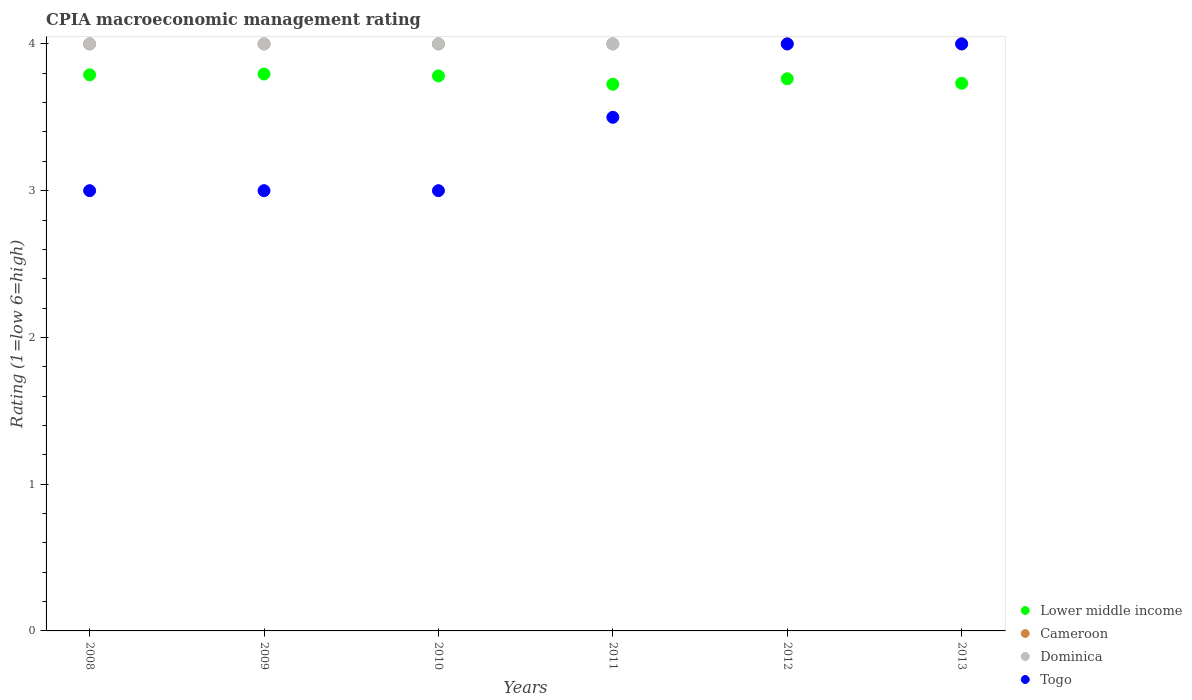Is the number of dotlines equal to the number of legend labels?
Offer a very short reply. Yes. What is the CPIA rating in Togo in 2013?
Provide a short and direct response. 4. Across all years, what is the maximum CPIA rating in Cameroon?
Ensure brevity in your answer.  4. In which year was the CPIA rating in Cameroon maximum?
Provide a short and direct response. 2008. What is the total CPIA rating in Cameroon in the graph?
Ensure brevity in your answer.  24. What is the difference between the CPIA rating in Dominica in 2008 and that in 2009?
Your answer should be very brief. 0. What is the difference between the CPIA rating in Lower middle income in 2010 and the CPIA rating in Dominica in 2009?
Keep it short and to the point. -0.22. In the year 2013, what is the difference between the CPIA rating in Dominica and CPIA rating in Lower middle income?
Offer a terse response. 0.27. What is the ratio of the CPIA rating in Lower middle income in 2010 to that in 2011?
Offer a terse response. 1.02. Is the difference between the CPIA rating in Dominica in 2009 and 2012 greater than the difference between the CPIA rating in Lower middle income in 2009 and 2012?
Give a very brief answer. No. What is the difference between the highest and the second highest CPIA rating in Togo?
Your answer should be compact. 0. Is the sum of the CPIA rating in Dominica in 2012 and 2013 greater than the maximum CPIA rating in Togo across all years?
Provide a succinct answer. Yes. Does the CPIA rating in Togo monotonically increase over the years?
Offer a very short reply. No. Is the CPIA rating in Cameroon strictly greater than the CPIA rating in Togo over the years?
Make the answer very short. No. Is the CPIA rating in Cameroon strictly less than the CPIA rating in Dominica over the years?
Give a very brief answer. No. How many years are there in the graph?
Offer a very short reply. 6. What is the difference between two consecutive major ticks on the Y-axis?
Provide a short and direct response. 1. Are the values on the major ticks of Y-axis written in scientific E-notation?
Your answer should be very brief. No. Does the graph contain grids?
Give a very brief answer. No. Where does the legend appear in the graph?
Your answer should be compact. Bottom right. What is the title of the graph?
Provide a short and direct response. CPIA macroeconomic management rating. Does "United States" appear as one of the legend labels in the graph?
Ensure brevity in your answer.  No. What is the label or title of the X-axis?
Keep it short and to the point. Years. What is the Rating (1=low 6=high) of Lower middle income in 2008?
Provide a succinct answer. 3.79. What is the Rating (1=low 6=high) of Cameroon in 2008?
Your answer should be compact. 4. What is the Rating (1=low 6=high) of Togo in 2008?
Provide a short and direct response. 3. What is the Rating (1=low 6=high) of Lower middle income in 2009?
Keep it short and to the point. 3.79. What is the Rating (1=low 6=high) of Lower middle income in 2010?
Offer a very short reply. 3.78. What is the Rating (1=low 6=high) of Cameroon in 2010?
Make the answer very short. 4. What is the Rating (1=low 6=high) in Togo in 2010?
Your answer should be compact. 3. What is the Rating (1=low 6=high) in Lower middle income in 2011?
Offer a very short reply. 3.73. What is the Rating (1=low 6=high) in Cameroon in 2011?
Offer a very short reply. 4. What is the Rating (1=low 6=high) of Dominica in 2011?
Offer a very short reply. 4. What is the Rating (1=low 6=high) of Lower middle income in 2012?
Your answer should be very brief. 3.76. What is the Rating (1=low 6=high) of Cameroon in 2012?
Ensure brevity in your answer.  4. What is the Rating (1=low 6=high) of Togo in 2012?
Offer a terse response. 4. What is the Rating (1=low 6=high) in Lower middle income in 2013?
Give a very brief answer. 3.73. What is the Rating (1=low 6=high) in Cameroon in 2013?
Keep it short and to the point. 4. What is the Rating (1=low 6=high) of Dominica in 2013?
Provide a short and direct response. 4. Across all years, what is the maximum Rating (1=low 6=high) of Lower middle income?
Provide a succinct answer. 3.79. Across all years, what is the maximum Rating (1=low 6=high) of Dominica?
Offer a terse response. 4. Across all years, what is the maximum Rating (1=low 6=high) of Togo?
Your answer should be very brief. 4. Across all years, what is the minimum Rating (1=low 6=high) in Lower middle income?
Offer a very short reply. 3.73. What is the total Rating (1=low 6=high) in Lower middle income in the graph?
Provide a short and direct response. 22.59. What is the total Rating (1=low 6=high) of Cameroon in the graph?
Your answer should be compact. 24. What is the difference between the Rating (1=low 6=high) in Lower middle income in 2008 and that in 2009?
Your answer should be very brief. -0.01. What is the difference between the Rating (1=low 6=high) in Cameroon in 2008 and that in 2009?
Make the answer very short. 0. What is the difference between the Rating (1=low 6=high) in Lower middle income in 2008 and that in 2010?
Offer a very short reply. 0.01. What is the difference between the Rating (1=low 6=high) in Cameroon in 2008 and that in 2010?
Provide a succinct answer. 0. What is the difference between the Rating (1=low 6=high) in Togo in 2008 and that in 2010?
Ensure brevity in your answer.  0. What is the difference between the Rating (1=low 6=high) in Lower middle income in 2008 and that in 2011?
Your answer should be compact. 0.06. What is the difference between the Rating (1=low 6=high) of Dominica in 2008 and that in 2011?
Provide a short and direct response. 0. What is the difference between the Rating (1=low 6=high) in Lower middle income in 2008 and that in 2012?
Make the answer very short. 0.03. What is the difference between the Rating (1=low 6=high) of Cameroon in 2008 and that in 2012?
Make the answer very short. 0. What is the difference between the Rating (1=low 6=high) in Dominica in 2008 and that in 2012?
Your answer should be very brief. 0. What is the difference between the Rating (1=low 6=high) of Lower middle income in 2008 and that in 2013?
Your answer should be very brief. 0.06. What is the difference between the Rating (1=low 6=high) of Cameroon in 2008 and that in 2013?
Keep it short and to the point. 0. What is the difference between the Rating (1=low 6=high) in Dominica in 2008 and that in 2013?
Your response must be concise. 0. What is the difference between the Rating (1=low 6=high) in Togo in 2008 and that in 2013?
Offer a very short reply. -1. What is the difference between the Rating (1=low 6=high) of Lower middle income in 2009 and that in 2010?
Ensure brevity in your answer.  0.01. What is the difference between the Rating (1=low 6=high) of Cameroon in 2009 and that in 2010?
Your answer should be very brief. 0. What is the difference between the Rating (1=low 6=high) in Lower middle income in 2009 and that in 2011?
Ensure brevity in your answer.  0.07. What is the difference between the Rating (1=low 6=high) of Togo in 2009 and that in 2011?
Provide a succinct answer. -0.5. What is the difference between the Rating (1=low 6=high) in Lower middle income in 2009 and that in 2012?
Give a very brief answer. 0.03. What is the difference between the Rating (1=low 6=high) of Cameroon in 2009 and that in 2012?
Make the answer very short. 0. What is the difference between the Rating (1=low 6=high) of Dominica in 2009 and that in 2012?
Offer a terse response. 0. What is the difference between the Rating (1=low 6=high) of Lower middle income in 2009 and that in 2013?
Ensure brevity in your answer.  0.06. What is the difference between the Rating (1=low 6=high) of Cameroon in 2009 and that in 2013?
Ensure brevity in your answer.  0. What is the difference between the Rating (1=low 6=high) of Lower middle income in 2010 and that in 2011?
Give a very brief answer. 0.06. What is the difference between the Rating (1=low 6=high) of Togo in 2010 and that in 2011?
Your response must be concise. -0.5. What is the difference between the Rating (1=low 6=high) of Lower middle income in 2010 and that in 2012?
Make the answer very short. 0.02. What is the difference between the Rating (1=low 6=high) of Lower middle income in 2010 and that in 2013?
Make the answer very short. 0.05. What is the difference between the Rating (1=low 6=high) of Dominica in 2010 and that in 2013?
Make the answer very short. 0. What is the difference between the Rating (1=low 6=high) of Togo in 2010 and that in 2013?
Make the answer very short. -1. What is the difference between the Rating (1=low 6=high) in Lower middle income in 2011 and that in 2012?
Ensure brevity in your answer.  -0.04. What is the difference between the Rating (1=low 6=high) in Cameroon in 2011 and that in 2012?
Keep it short and to the point. 0. What is the difference between the Rating (1=low 6=high) of Lower middle income in 2011 and that in 2013?
Provide a short and direct response. -0.01. What is the difference between the Rating (1=low 6=high) of Dominica in 2011 and that in 2013?
Your answer should be very brief. 0. What is the difference between the Rating (1=low 6=high) of Togo in 2011 and that in 2013?
Offer a terse response. -0.5. What is the difference between the Rating (1=low 6=high) of Lower middle income in 2012 and that in 2013?
Provide a succinct answer. 0.03. What is the difference between the Rating (1=low 6=high) in Cameroon in 2012 and that in 2013?
Make the answer very short. 0. What is the difference between the Rating (1=low 6=high) of Dominica in 2012 and that in 2013?
Make the answer very short. 0. What is the difference between the Rating (1=low 6=high) of Lower middle income in 2008 and the Rating (1=low 6=high) of Cameroon in 2009?
Keep it short and to the point. -0.21. What is the difference between the Rating (1=low 6=high) in Lower middle income in 2008 and the Rating (1=low 6=high) in Dominica in 2009?
Keep it short and to the point. -0.21. What is the difference between the Rating (1=low 6=high) of Lower middle income in 2008 and the Rating (1=low 6=high) of Togo in 2009?
Ensure brevity in your answer.  0.79. What is the difference between the Rating (1=low 6=high) of Cameroon in 2008 and the Rating (1=low 6=high) of Togo in 2009?
Your answer should be compact. 1. What is the difference between the Rating (1=low 6=high) in Dominica in 2008 and the Rating (1=low 6=high) in Togo in 2009?
Keep it short and to the point. 1. What is the difference between the Rating (1=low 6=high) in Lower middle income in 2008 and the Rating (1=low 6=high) in Cameroon in 2010?
Give a very brief answer. -0.21. What is the difference between the Rating (1=low 6=high) in Lower middle income in 2008 and the Rating (1=low 6=high) in Dominica in 2010?
Make the answer very short. -0.21. What is the difference between the Rating (1=low 6=high) in Lower middle income in 2008 and the Rating (1=low 6=high) in Togo in 2010?
Provide a succinct answer. 0.79. What is the difference between the Rating (1=low 6=high) of Dominica in 2008 and the Rating (1=low 6=high) of Togo in 2010?
Make the answer very short. 1. What is the difference between the Rating (1=low 6=high) in Lower middle income in 2008 and the Rating (1=low 6=high) in Cameroon in 2011?
Provide a short and direct response. -0.21. What is the difference between the Rating (1=low 6=high) of Lower middle income in 2008 and the Rating (1=low 6=high) of Dominica in 2011?
Your answer should be compact. -0.21. What is the difference between the Rating (1=low 6=high) in Lower middle income in 2008 and the Rating (1=low 6=high) in Togo in 2011?
Give a very brief answer. 0.29. What is the difference between the Rating (1=low 6=high) of Cameroon in 2008 and the Rating (1=low 6=high) of Dominica in 2011?
Your response must be concise. 0. What is the difference between the Rating (1=low 6=high) of Lower middle income in 2008 and the Rating (1=low 6=high) of Cameroon in 2012?
Provide a succinct answer. -0.21. What is the difference between the Rating (1=low 6=high) of Lower middle income in 2008 and the Rating (1=low 6=high) of Dominica in 2012?
Provide a short and direct response. -0.21. What is the difference between the Rating (1=low 6=high) of Lower middle income in 2008 and the Rating (1=low 6=high) of Togo in 2012?
Offer a terse response. -0.21. What is the difference between the Rating (1=low 6=high) in Cameroon in 2008 and the Rating (1=low 6=high) in Togo in 2012?
Give a very brief answer. 0. What is the difference between the Rating (1=low 6=high) of Dominica in 2008 and the Rating (1=low 6=high) of Togo in 2012?
Make the answer very short. 0. What is the difference between the Rating (1=low 6=high) of Lower middle income in 2008 and the Rating (1=low 6=high) of Cameroon in 2013?
Provide a short and direct response. -0.21. What is the difference between the Rating (1=low 6=high) in Lower middle income in 2008 and the Rating (1=low 6=high) in Dominica in 2013?
Offer a very short reply. -0.21. What is the difference between the Rating (1=low 6=high) of Lower middle income in 2008 and the Rating (1=low 6=high) of Togo in 2013?
Provide a succinct answer. -0.21. What is the difference between the Rating (1=low 6=high) in Cameroon in 2008 and the Rating (1=low 6=high) in Togo in 2013?
Offer a terse response. 0. What is the difference between the Rating (1=low 6=high) in Dominica in 2008 and the Rating (1=low 6=high) in Togo in 2013?
Offer a very short reply. 0. What is the difference between the Rating (1=low 6=high) of Lower middle income in 2009 and the Rating (1=low 6=high) of Cameroon in 2010?
Your answer should be compact. -0.21. What is the difference between the Rating (1=low 6=high) of Lower middle income in 2009 and the Rating (1=low 6=high) of Dominica in 2010?
Give a very brief answer. -0.21. What is the difference between the Rating (1=low 6=high) of Lower middle income in 2009 and the Rating (1=low 6=high) of Togo in 2010?
Make the answer very short. 0.79. What is the difference between the Rating (1=low 6=high) in Cameroon in 2009 and the Rating (1=low 6=high) in Dominica in 2010?
Make the answer very short. 0. What is the difference between the Rating (1=low 6=high) in Cameroon in 2009 and the Rating (1=low 6=high) in Togo in 2010?
Offer a terse response. 1. What is the difference between the Rating (1=low 6=high) of Lower middle income in 2009 and the Rating (1=low 6=high) of Cameroon in 2011?
Provide a succinct answer. -0.21. What is the difference between the Rating (1=low 6=high) of Lower middle income in 2009 and the Rating (1=low 6=high) of Dominica in 2011?
Your answer should be compact. -0.21. What is the difference between the Rating (1=low 6=high) in Lower middle income in 2009 and the Rating (1=low 6=high) in Togo in 2011?
Keep it short and to the point. 0.29. What is the difference between the Rating (1=low 6=high) of Cameroon in 2009 and the Rating (1=low 6=high) of Togo in 2011?
Provide a succinct answer. 0.5. What is the difference between the Rating (1=low 6=high) in Dominica in 2009 and the Rating (1=low 6=high) in Togo in 2011?
Keep it short and to the point. 0.5. What is the difference between the Rating (1=low 6=high) in Lower middle income in 2009 and the Rating (1=low 6=high) in Cameroon in 2012?
Provide a succinct answer. -0.21. What is the difference between the Rating (1=low 6=high) in Lower middle income in 2009 and the Rating (1=low 6=high) in Dominica in 2012?
Give a very brief answer. -0.21. What is the difference between the Rating (1=low 6=high) in Lower middle income in 2009 and the Rating (1=low 6=high) in Togo in 2012?
Your answer should be compact. -0.21. What is the difference between the Rating (1=low 6=high) in Cameroon in 2009 and the Rating (1=low 6=high) in Dominica in 2012?
Keep it short and to the point. 0. What is the difference between the Rating (1=low 6=high) of Dominica in 2009 and the Rating (1=low 6=high) of Togo in 2012?
Keep it short and to the point. 0. What is the difference between the Rating (1=low 6=high) in Lower middle income in 2009 and the Rating (1=low 6=high) in Cameroon in 2013?
Make the answer very short. -0.21. What is the difference between the Rating (1=low 6=high) in Lower middle income in 2009 and the Rating (1=low 6=high) in Dominica in 2013?
Your response must be concise. -0.21. What is the difference between the Rating (1=low 6=high) of Lower middle income in 2009 and the Rating (1=low 6=high) of Togo in 2013?
Ensure brevity in your answer.  -0.21. What is the difference between the Rating (1=low 6=high) of Cameroon in 2009 and the Rating (1=low 6=high) of Dominica in 2013?
Keep it short and to the point. 0. What is the difference between the Rating (1=low 6=high) of Cameroon in 2009 and the Rating (1=low 6=high) of Togo in 2013?
Offer a terse response. 0. What is the difference between the Rating (1=low 6=high) in Dominica in 2009 and the Rating (1=low 6=high) in Togo in 2013?
Ensure brevity in your answer.  0. What is the difference between the Rating (1=low 6=high) of Lower middle income in 2010 and the Rating (1=low 6=high) of Cameroon in 2011?
Keep it short and to the point. -0.22. What is the difference between the Rating (1=low 6=high) in Lower middle income in 2010 and the Rating (1=low 6=high) in Dominica in 2011?
Give a very brief answer. -0.22. What is the difference between the Rating (1=low 6=high) in Lower middle income in 2010 and the Rating (1=low 6=high) in Togo in 2011?
Provide a succinct answer. 0.28. What is the difference between the Rating (1=low 6=high) in Cameroon in 2010 and the Rating (1=low 6=high) in Togo in 2011?
Offer a very short reply. 0.5. What is the difference between the Rating (1=low 6=high) of Dominica in 2010 and the Rating (1=low 6=high) of Togo in 2011?
Your response must be concise. 0.5. What is the difference between the Rating (1=low 6=high) of Lower middle income in 2010 and the Rating (1=low 6=high) of Cameroon in 2012?
Make the answer very short. -0.22. What is the difference between the Rating (1=low 6=high) of Lower middle income in 2010 and the Rating (1=low 6=high) of Dominica in 2012?
Offer a very short reply. -0.22. What is the difference between the Rating (1=low 6=high) of Lower middle income in 2010 and the Rating (1=low 6=high) of Togo in 2012?
Provide a short and direct response. -0.22. What is the difference between the Rating (1=low 6=high) in Cameroon in 2010 and the Rating (1=low 6=high) in Dominica in 2012?
Provide a short and direct response. 0. What is the difference between the Rating (1=low 6=high) in Dominica in 2010 and the Rating (1=low 6=high) in Togo in 2012?
Your answer should be compact. 0. What is the difference between the Rating (1=low 6=high) of Lower middle income in 2010 and the Rating (1=low 6=high) of Cameroon in 2013?
Your answer should be very brief. -0.22. What is the difference between the Rating (1=low 6=high) in Lower middle income in 2010 and the Rating (1=low 6=high) in Dominica in 2013?
Your answer should be very brief. -0.22. What is the difference between the Rating (1=low 6=high) of Lower middle income in 2010 and the Rating (1=low 6=high) of Togo in 2013?
Ensure brevity in your answer.  -0.22. What is the difference between the Rating (1=low 6=high) in Cameroon in 2010 and the Rating (1=low 6=high) in Dominica in 2013?
Make the answer very short. 0. What is the difference between the Rating (1=low 6=high) in Dominica in 2010 and the Rating (1=low 6=high) in Togo in 2013?
Ensure brevity in your answer.  0. What is the difference between the Rating (1=low 6=high) in Lower middle income in 2011 and the Rating (1=low 6=high) in Cameroon in 2012?
Keep it short and to the point. -0.28. What is the difference between the Rating (1=low 6=high) of Lower middle income in 2011 and the Rating (1=low 6=high) of Dominica in 2012?
Keep it short and to the point. -0.28. What is the difference between the Rating (1=low 6=high) of Lower middle income in 2011 and the Rating (1=low 6=high) of Togo in 2012?
Ensure brevity in your answer.  -0.28. What is the difference between the Rating (1=low 6=high) in Dominica in 2011 and the Rating (1=low 6=high) in Togo in 2012?
Make the answer very short. 0. What is the difference between the Rating (1=low 6=high) of Lower middle income in 2011 and the Rating (1=low 6=high) of Cameroon in 2013?
Ensure brevity in your answer.  -0.28. What is the difference between the Rating (1=low 6=high) of Lower middle income in 2011 and the Rating (1=low 6=high) of Dominica in 2013?
Provide a succinct answer. -0.28. What is the difference between the Rating (1=low 6=high) in Lower middle income in 2011 and the Rating (1=low 6=high) in Togo in 2013?
Your answer should be compact. -0.28. What is the difference between the Rating (1=low 6=high) of Dominica in 2011 and the Rating (1=low 6=high) of Togo in 2013?
Ensure brevity in your answer.  0. What is the difference between the Rating (1=low 6=high) of Lower middle income in 2012 and the Rating (1=low 6=high) of Cameroon in 2013?
Your answer should be very brief. -0.24. What is the difference between the Rating (1=low 6=high) in Lower middle income in 2012 and the Rating (1=low 6=high) in Dominica in 2013?
Ensure brevity in your answer.  -0.24. What is the difference between the Rating (1=low 6=high) in Lower middle income in 2012 and the Rating (1=low 6=high) in Togo in 2013?
Ensure brevity in your answer.  -0.24. What is the difference between the Rating (1=low 6=high) in Cameroon in 2012 and the Rating (1=low 6=high) in Dominica in 2013?
Offer a terse response. 0. What is the average Rating (1=low 6=high) in Lower middle income per year?
Your response must be concise. 3.76. What is the average Rating (1=low 6=high) in Dominica per year?
Your answer should be very brief. 4. What is the average Rating (1=low 6=high) of Togo per year?
Give a very brief answer. 3.42. In the year 2008, what is the difference between the Rating (1=low 6=high) in Lower middle income and Rating (1=low 6=high) in Cameroon?
Ensure brevity in your answer.  -0.21. In the year 2008, what is the difference between the Rating (1=low 6=high) in Lower middle income and Rating (1=low 6=high) in Dominica?
Your answer should be compact. -0.21. In the year 2008, what is the difference between the Rating (1=low 6=high) of Lower middle income and Rating (1=low 6=high) of Togo?
Your response must be concise. 0.79. In the year 2008, what is the difference between the Rating (1=low 6=high) of Cameroon and Rating (1=low 6=high) of Dominica?
Offer a terse response. 0. In the year 2009, what is the difference between the Rating (1=low 6=high) of Lower middle income and Rating (1=low 6=high) of Cameroon?
Ensure brevity in your answer.  -0.21. In the year 2009, what is the difference between the Rating (1=low 6=high) in Lower middle income and Rating (1=low 6=high) in Dominica?
Provide a succinct answer. -0.21. In the year 2009, what is the difference between the Rating (1=low 6=high) of Lower middle income and Rating (1=low 6=high) of Togo?
Ensure brevity in your answer.  0.79. In the year 2010, what is the difference between the Rating (1=low 6=high) of Lower middle income and Rating (1=low 6=high) of Cameroon?
Give a very brief answer. -0.22. In the year 2010, what is the difference between the Rating (1=low 6=high) of Lower middle income and Rating (1=low 6=high) of Dominica?
Your answer should be very brief. -0.22. In the year 2010, what is the difference between the Rating (1=low 6=high) in Lower middle income and Rating (1=low 6=high) in Togo?
Ensure brevity in your answer.  0.78. In the year 2010, what is the difference between the Rating (1=low 6=high) in Cameroon and Rating (1=low 6=high) in Togo?
Give a very brief answer. 1. In the year 2011, what is the difference between the Rating (1=low 6=high) in Lower middle income and Rating (1=low 6=high) in Cameroon?
Your response must be concise. -0.28. In the year 2011, what is the difference between the Rating (1=low 6=high) in Lower middle income and Rating (1=low 6=high) in Dominica?
Your answer should be very brief. -0.28. In the year 2011, what is the difference between the Rating (1=low 6=high) in Lower middle income and Rating (1=low 6=high) in Togo?
Your response must be concise. 0.23. In the year 2012, what is the difference between the Rating (1=low 6=high) of Lower middle income and Rating (1=low 6=high) of Cameroon?
Your response must be concise. -0.24. In the year 2012, what is the difference between the Rating (1=low 6=high) of Lower middle income and Rating (1=low 6=high) of Dominica?
Give a very brief answer. -0.24. In the year 2012, what is the difference between the Rating (1=low 6=high) of Lower middle income and Rating (1=low 6=high) of Togo?
Provide a succinct answer. -0.24. In the year 2012, what is the difference between the Rating (1=low 6=high) of Cameroon and Rating (1=low 6=high) of Dominica?
Provide a succinct answer. 0. In the year 2012, what is the difference between the Rating (1=low 6=high) in Cameroon and Rating (1=low 6=high) in Togo?
Your answer should be compact. 0. In the year 2012, what is the difference between the Rating (1=low 6=high) of Dominica and Rating (1=low 6=high) of Togo?
Keep it short and to the point. 0. In the year 2013, what is the difference between the Rating (1=low 6=high) in Lower middle income and Rating (1=low 6=high) in Cameroon?
Your answer should be very brief. -0.27. In the year 2013, what is the difference between the Rating (1=low 6=high) in Lower middle income and Rating (1=low 6=high) in Dominica?
Keep it short and to the point. -0.27. In the year 2013, what is the difference between the Rating (1=low 6=high) of Lower middle income and Rating (1=low 6=high) of Togo?
Your answer should be compact. -0.27. In the year 2013, what is the difference between the Rating (1=low 6=high) in Cameroon and Rating (1=low 6=high) in Dominica?
Ensure brevity in your answer.  0. What is the ratio of the Rating (1=low 6=high) of Lower middle income in 2008 to that in 2009?
Make the answer very short. 1. What is the ratio of the Rating (1=low 6=high) in Dominica in 2008 to that in 2009?
Make the answer very short. 1. What is the ratio of the Rating (1=low 6=high) of Togo in 2008 to that in 2009?
Make the answer very short. 1. What is the ratio of the Rating (1=low 6=high) in Lower middle income in 2008 to that in 2011?
Your answer should be very brief. 1.02. What is the ratio of the Rating (1=low 6=high) of Togo in 2008 to that in 2011?
Give a very brief answer. 0.86. What is the ratio of the Rating (1=low 6=high) in Cameroon in 2008 to that in 2012?
Ensure brevity in your answer.  1. What is the ratio of the Rating (1=low 6=high) of Togo in 2008 to that in 2012?
Ensure brevity in your answer.  0.75. What is the ratio of the Rating (1=low 6=high) of Lower middle income in 2008 to that in 2013?
Ensure brevity in your answer.  1.02. What is the ratio of the Rating (1=low 6=high) in Dominica in 2008 to that in 2013?
Ensure brevity in your answer.  1. What is the ratio of the Rating (1=low 6=high) in Lower middle income in 2009 to that in 2011?
Offer a terse response. 1.02. What is the ratio of the Rating (1=low 6=high) of Cameroon in 2009 to that in 2011?
Give a very brief answer. 1. What is the ratio of the Rating (1=low 6=high) in Togo in 2009 to that in 2011?
Provide a short and direct response. 0.86. What is the ratio of the Rating (1=low 6=high) of Lower middle income in 2009 to that in 2012?
Your answer should be very brief. 1.01. What is the ratio of the Rating (1=low 6=high) of Lower middle income in 2009 to that in 2013?
Make the answer very short. 1.02. What is the ratio of the Rating (1=low 6=high) of Cameroon in 2009 to that in 2013?
Your response must be concise. 1. What is the ratio of the Rating (1=low 6=high) of Dominica in 2009 to that in 2013?
Provide a short and direct response. 1. What is the ratio of the Rating (1=low 6=high) of Togo in 2009 to that in 2013?
Your answer should be compact. 0.75. What is the ratio of the Rating (1=low 6=high) in Lower middle income in 2010 to that in 2011?
Provide a short and direct response. 1.02. What is the ratio of the Rating (1=low 6=high) of Dominica in 2010 to that in 2011?
Ensure brevity in your answer.  1. What is the ratio of the Rating (1=low 6=high) of Togo in 2010 to that in 2011?
Ensure brevity in your answer.  0.86. What is the ratio of the Rating (1=low 6=high) in Lower middle income in 2010 to that in 2012?
Provide a short and direct response. 1.01. What is the ratio of the Rating (1=low 6=high) of Dominica in 2010 to that in 2012?
Provide a succinct answer. 1. What is the ratio of the Rating (1=low 6=high) in Lower middle income in 2010 to that in 2013?
Offer a very short reply. 1.01. What is the ratio of the Rating (1=low 6=high) in Dominica in 2010 to that in 2013?
Offer a terse response. 1. What is the ratio of the Rating (1=low 6=high) of Togo in 2010 to that in 2013?
Provide a short and direct response. 0.75. What is the ratio of the Rating (1=low 6=high) in Lower middle income in 2011 to that in 2012?
Make the answer very short. 0.99. What is the ratio of the Rating (1=low 6=high) of Cameroon in 2011 to that in 2012?
Keep it short and to the point. 1. What is the ratio of the Rating (1=low 6=high) of Togo in 2011 to that in 2012?
Offer a terse response. 0.88. What is the ratio of the Rating (1=low 6=high) in Cameroon in 2011 to that in 2013?
Make the answer very short. 1. What is the ratio of the Rating (1=low 6=high) of Dominica in 2011 to that in 2013?
Give a very brief answer. 1. What is the ratio of the Rating (1=low 6=high) in Togo in 2011 to that in 2013?
Make the answer very short. 0.88. What is the ratio of the Rating (1=low 6=high) in Lower middle income in 2012 to that in 2013?
Make the answer very short. 1.01. What is the difference between the highest and the second highest Rating (1=low 6=high) of Lower middle income?
Provide a succinct answer. 0.01. What is the difference between the highest and the second highest Rating (1=low 6=high) in Cameroon?
Provide a succinct answer. 0. What is the difference between the highest and the second highest Rating (1=low 6=high) of Dominica?
Keep it short and to the point. 0. What is the difference between the highest and the lowest Rating (1=low 6=high) in Lower middle income?
Keep it short and to the point. 0.07. What is the difference between the highest and the lowest Rating (1=low 6=high) in Cameroon?
Offer a terse response. 0. What is the difference between the highest and the lowest Rating (1=low 6=high) in Dominica?
Give a very brief answer. 0. What is the difference between the highest and the lowest Rating (1=low 6=high) in Togo?
Offer a terse response. 1. 